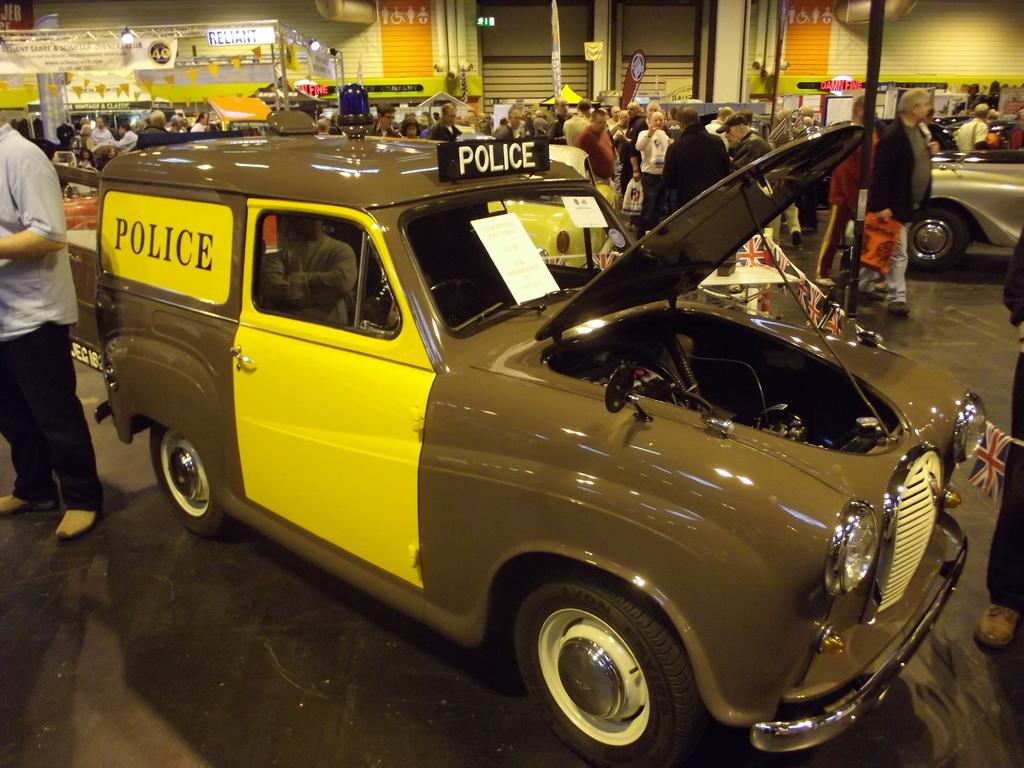What are the people in the image doing? The group of people is standing on the road. What vehicle is present in the image? There is a car in the image. What features can be seen on the car? The car has a windshield and tires. What else is present in the image besides the people and the car? There is a pole in the image. What is the purpose of the lights on the pole? The lights on the pole might be for illumination or signaling. What type of cherries are being served on the plate in the image? There is no plate or cherries present in the image. What color is the orange on the road in the image? There is no orange present on the road in the image. 